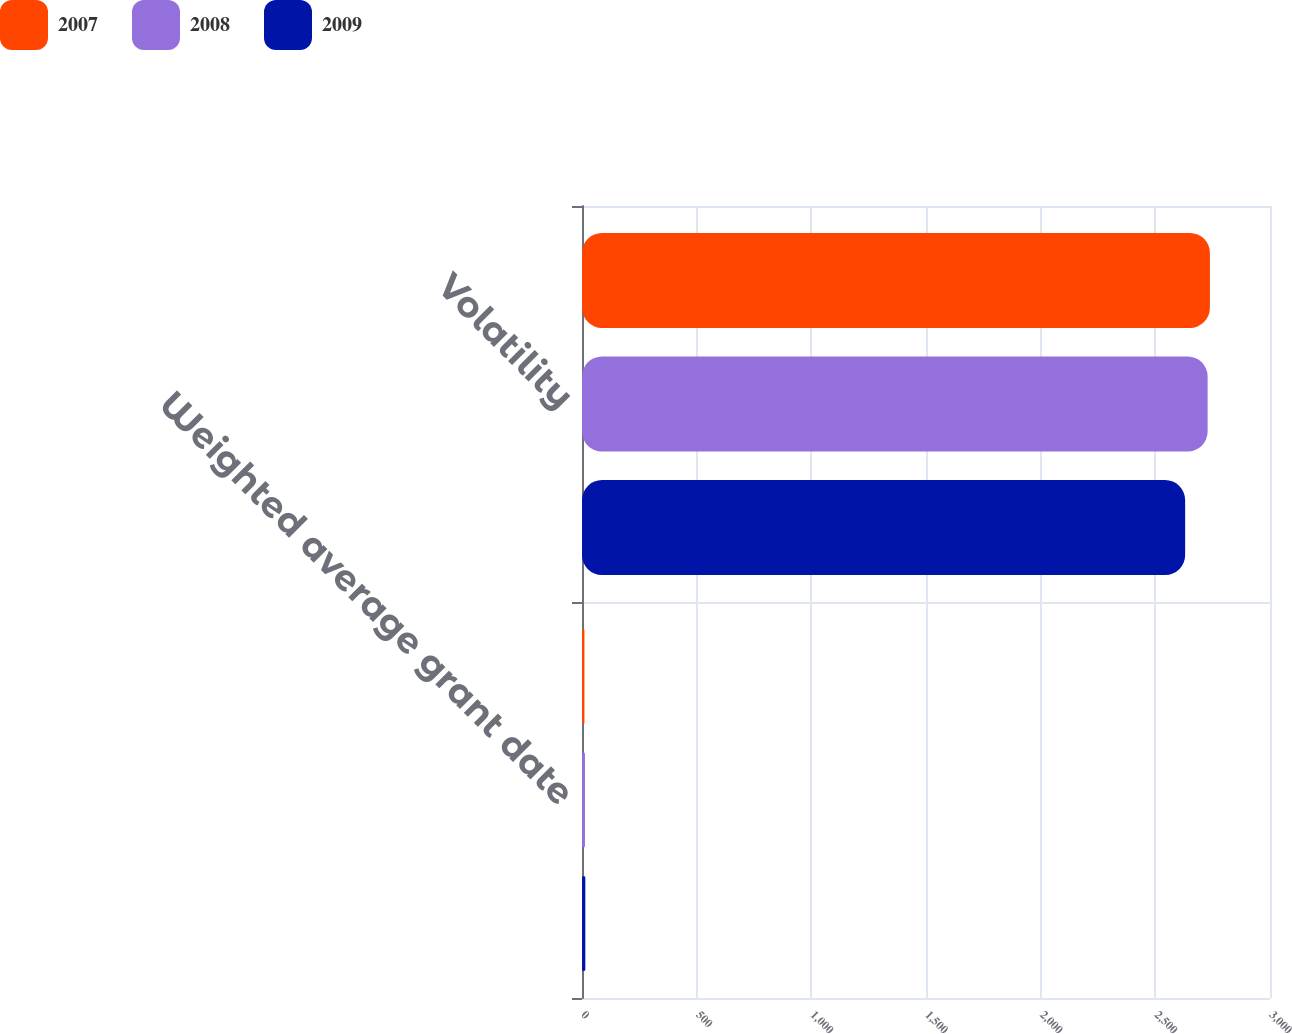<chart> <loc_0><loc_0><loc_500><loc_500><stacked_bar_chart><ecel><fcel>Weighted average grant date<fcel>Volatility<nl><fcel>2007<fcel>10.58<fcel>2738<nl><fcel>2008<fcel>12.87<fcel>2728<nl><fcel>2009<fcel>14.53<fcel>2630<nl></chart> 